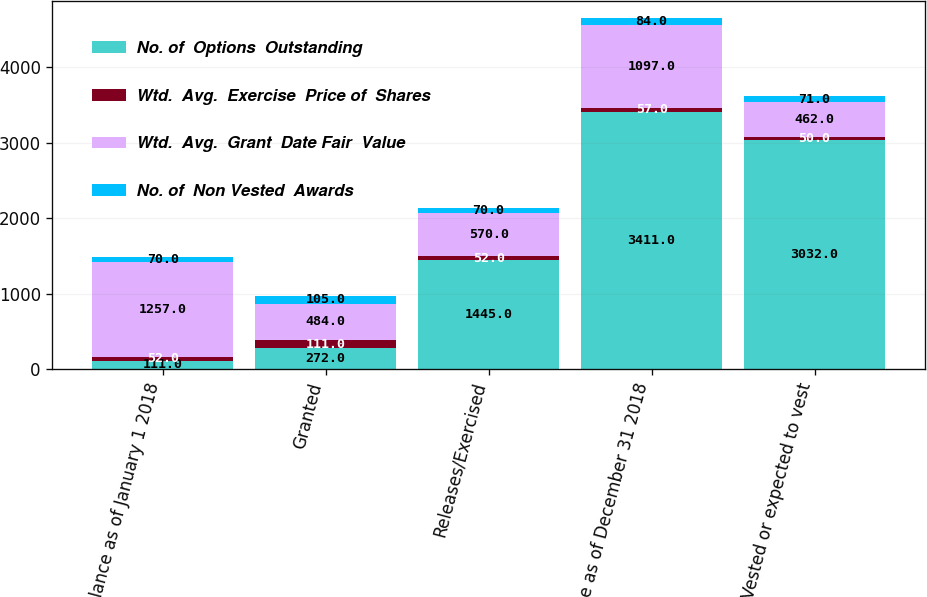Convert chart. <chart><loc_0><loc_0><loc_500><loc_500><stacked_bar_chart><ecel><fcel>Balance as of January 1 2018<fcel>Granted<fcel>Releases/Exercised<fcel>Balance as of December 31 2018<fcel>Vested or expected to vest<nl><fcel>No. of  Options  Outstanding<fcel>111<fcel>272<fcel>1445<fcel>3411<fcel>3032<nl><fcel>Wtd.  Avg.  Exercise  Price of  Shares<fcel>52<fcel>111<fcel>52<fcel>57<fcel>50<nl><fcel>Wtd.  Avg.  Grant  Date Fair  Value<fcel>1257<fcel>484<fcel>570<fcel>1097<fcel>462<nl><fcel>No. of  Non Vested  Awards<fcel>70<fcel>105<fcel>70<fcel>84<fcel>71<nl></chart> 